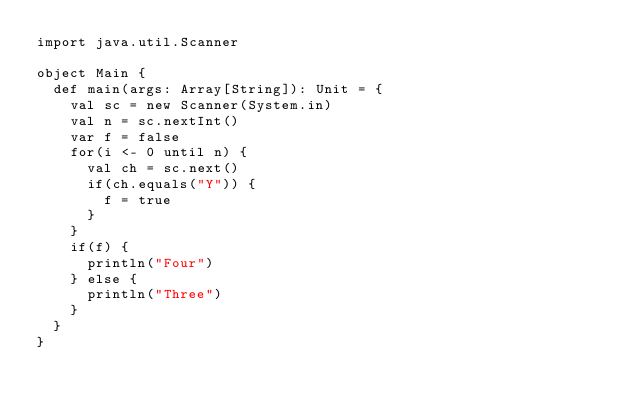<code> <loc_0><loc_0><loc_500><loc_500><_Scala_>import java.util.Scanner

object Main {
  def main(args: Array[String]): Unit = {
    val sc = new Scanner(System.in)
    val n = sc.nextInt()
    var f = false
    for(i <- 0 until n) {
      val ch = sc.next()
      if(ch.equals("Y")) {
        f = true
      }
    }
    if(f) {
      println("Four")
    } else {
      println("Three")
    }
  }
}
</code> 